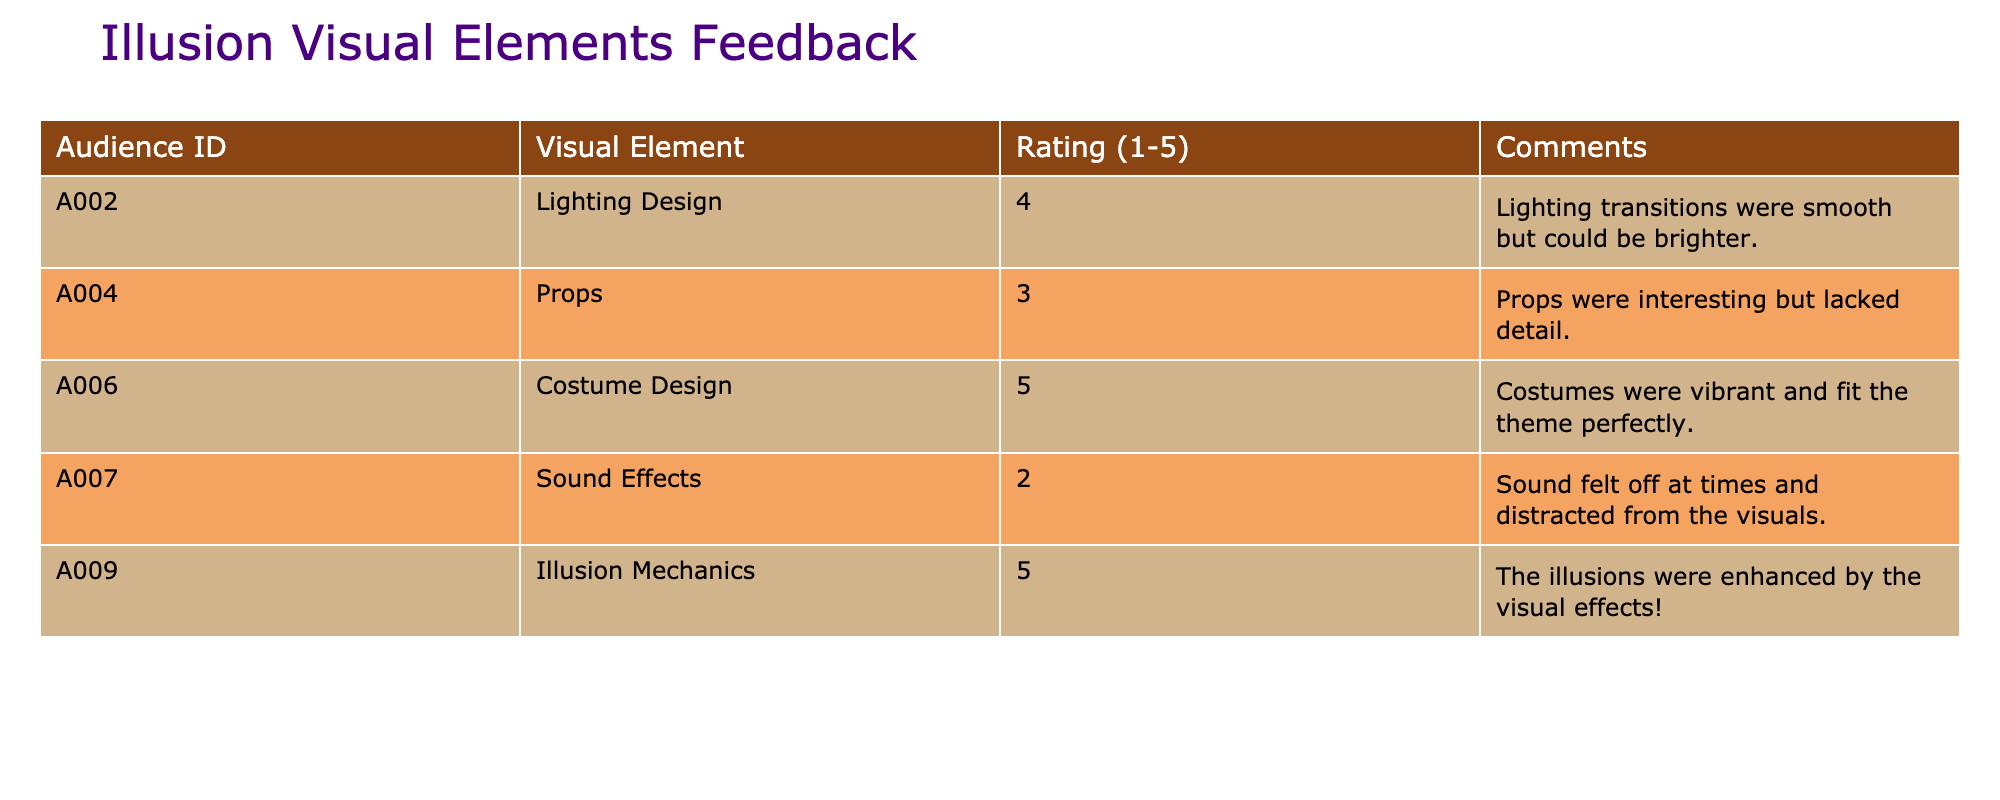What is the highest rating given to a visual element? The ratings for visual elements are 4, 3, 5, 2, and 5. Among these, the highest rating is 5.
Answer: 5 What visual element received a rating of 2? The table shows that the "Sound Effects" visual element received a rating of 2.
Answer: Sound Effects How many visual elements received a rating of 5? There are two entries in the table with a rating of 5: "Costume Design" and "Illusion Mechanics." Therefore, there are two visual elements with this rating.
Answer: 2 What is the average rating of all the visual elements? The ratings are 4, 3, 5, 2, and 5. Summing them gives 19 (4 + 3 + 5 + 2 + 5 = 19). Since there are 5 elements, the average rating is 19 / 5 = 3.8.
Answer: 3.8 Did any visual element receive a rating of 3 or lower? Yes, "Props" received a rating of 3 and "Sound Effects" received a rating of 2, indicating that at least one visual element has a rating of 3 or lower.
Answer: Yes Which visual element has the most detailed audience feedback comments? The comments provided for each visual element vary in specificity. The comment for "Costume Design" is very positive and specific about vibrancy and theme fit. Other comments are less detailed or more critical. Thus, "Costume Design" stands out as having the most positive detail in the feedback.
Answer: Costume Design Are there any visual elements with comments related to enhancement or distraction? Yes, "Illusion Mechanics" has a comment mentioning enhancement, while "Sound Effects" has a comment regarding distraction from the visuals, indicating both types of feedback are present in the table.
Answer: Yes What is the rating difference between the highest and lowest rated visual elements? The highest rating is for "Costume Design" and "Illusion Mechanics" at 5, while the lowest rating is for "Sound Effects" at 2. Therefore, the difference is 5 - 2 = 3.
Answer: 3 Which visual element had the least favorable comment? The comment for "Sound Effects" was the least favorable, as it mentioned the sound distracting from the visuals, indicating dissatisfaction.
Answer: Sound Effects 